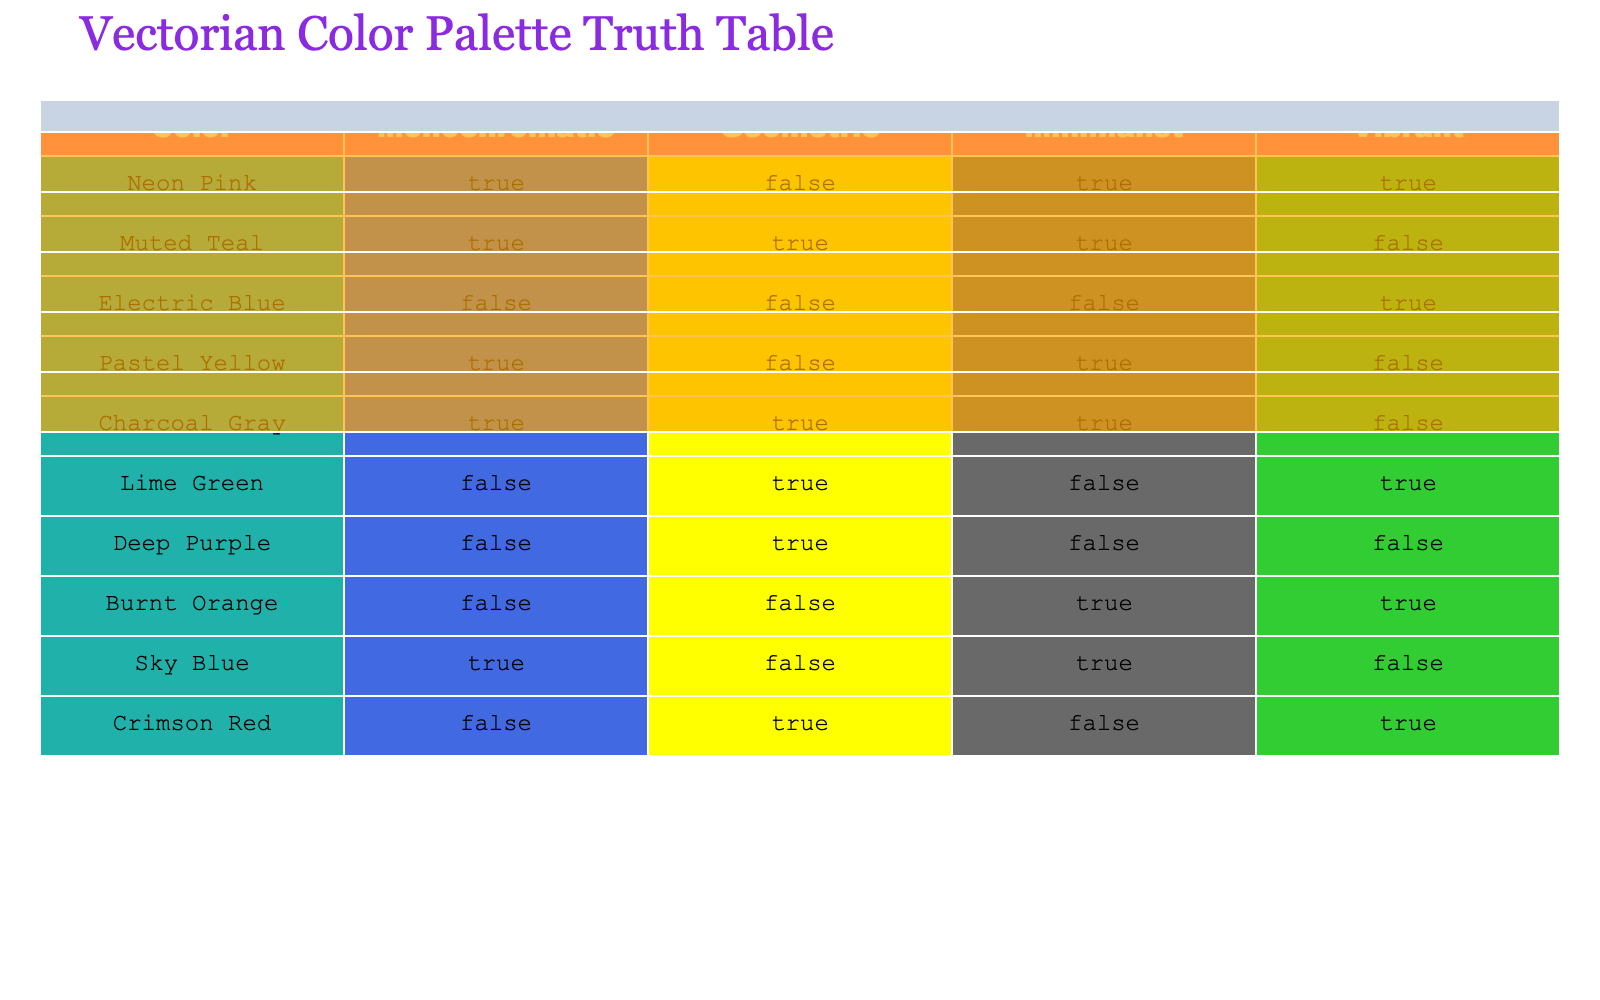What color is both Monochromatic and Minimalist? Look at the 'Monochromatic' column and 'Minimalist' column. The color 'Pastel Yellow' has TRUE in both columns, indicating it is both Monochromatic and Minimalist.
Answer: Pastel Yellow How many colors are categorized as Vibrant? By reviewing the 'Vibrant' column, I see that there are 4 colors marked as TRUE, which are Neon Pink, Electric Blue, Burnt Orange, and Crimson Red.
Answer: 4 Is Charcoal Gray considered Geometric? Checking the 'Charcoal Gray' row in the 'Geometric' column, I see it has a FALSE value, meaning Charcoal Gray is not categorized as Geometric.
Answer: No Which color has the highest number of TRUE values across all categories? First, I will count the TRUE values in each row. 'Muted Teal' has 4 TRUE values, more than any other color. The others have fewer than 4.
Answer: Muted Teal Can a color be both Vibrant and Monochromatic at the same time? Looking at the table, I find 'Neon Pink' and 'Pastel Yellow' are TRUE in both 'Vibrant' and 'Monochromatic' columns, hence it is possible.
Answer: Yes What is the average TRUE count for the colors listed? We have 10 colors in total. Adding up all the TRUE values gives us 21. To find the average: 21 values / 10 colors = 2.1.
Answer: 2.1 How many colors are neither Monochromatic nor Minimalist? By examining the table, 'Electric Blue', 'Deep Purple', and 'Lime Green' are FALSE in both 'Monochromatic' and 'Minimalist', totaling to 3 colors.
Answer: 3 Which color is excluded from being Monochromatic and characteristics of at least one other style? The 'Deep Purple' color is marked FALSE for 'Monochromatic' but is TRUE for 'Geometric'. Thus, it matches the criteria.
Answer: Deep Purple 